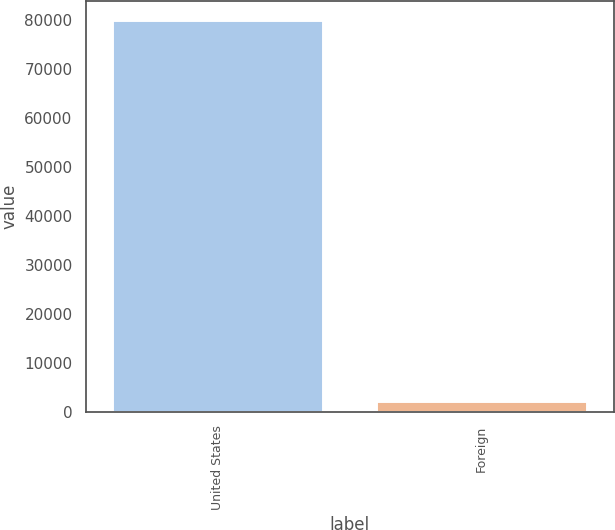Convert chart to OTSL. <chart><loc_0><loc_0><loc_500><loc_500><bar_chart><fcel>United States<fcel>Foreign<nl><fcel>79931<fcel>2257<nl></chart> 